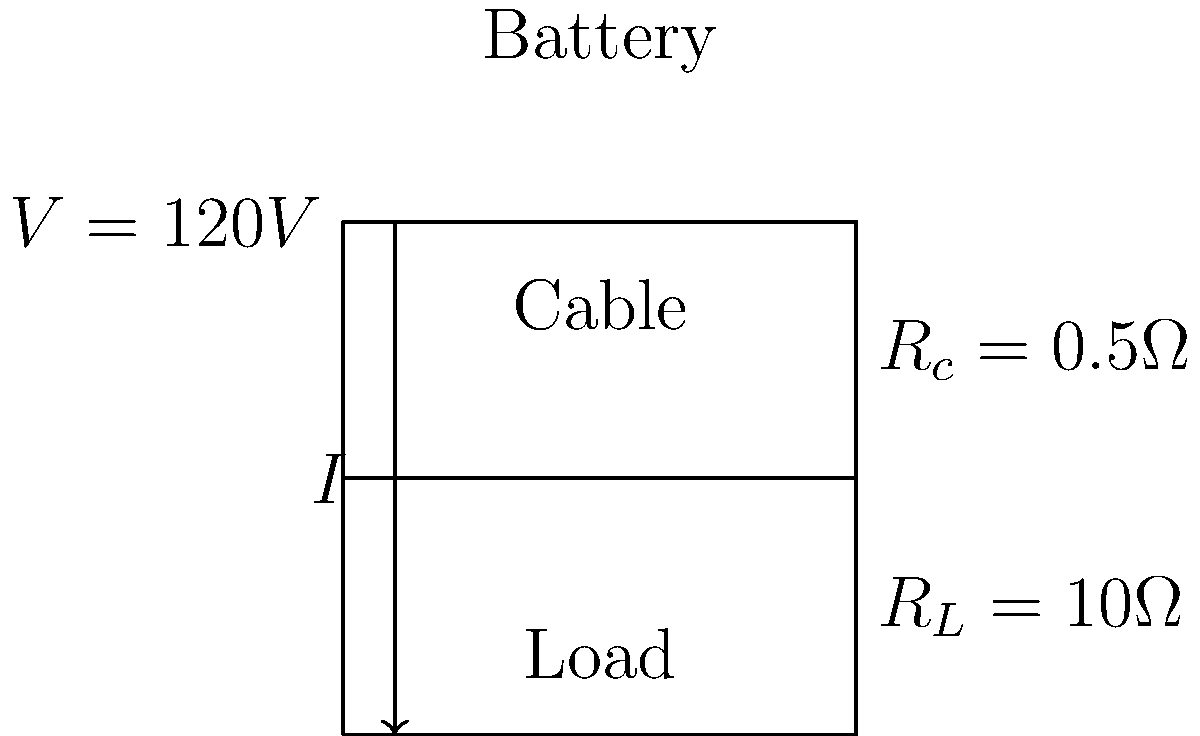At a community sports festival, you're responsible for powering temporary structures using long cables. Given the simplified circuit diagram above, where a 120V power source is connected to a load through a cable with resistance, calculate the voltage drop across the cable. Assume the cable has a resistance of 0.5Ω and the load has a resistance of 10Ω. To calculate the voltage drop across the cable, we'll follow these steps:

1) First, we need to calculate the total current in the circuit using Ohm's Law:
   
   $I = \frac{V}{R_{\text{total}}}$

2) The total resistance is the sum of the cable resistance and load resistance:
   
   $R_{\text{total}} = R_c + R_L = 0.5\Omega + 10\Omega = 10.5\Omega$

3) Now we can calculate the current:
   
   $I = \frac{120V}{10.5\Omega} = 11.43A$

4) The voltage drop across the cable is given by Ohm's Law applied to the cable:
   
   $V_{\text{drop}} = I \times R_c = 11.43A \times 0.5\Omega = 5.71V$

Therefore, the voltage drop across the cable is approximately 5.71V.
Answer: 5.71V 